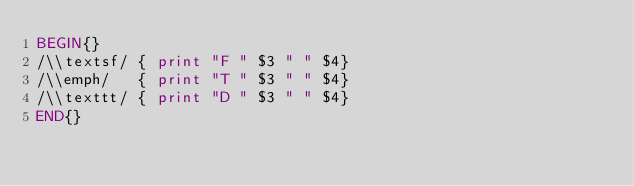Convert code to text. <code><loc_0><loc_0><loc_500><loc_500><_Awk_>BEGIN{}
/\\textsf/ { print "F " $3 " " $4}
/\\emph/   { print "T " $3 " " $4}
/\\texttt/ { print "D " $3 " " $4}
END{}
</code> 